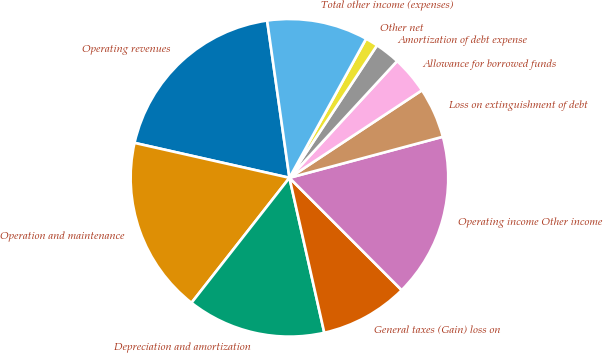Convert chart. <chart><loc_0><loc_0><loc_500><loc_500><pie_chart><fcel>Operating revenues<fcel>Operation and maintenance<fcel>Depreciation and amortization<fcel>General taxes (Gain) loss on<fcel>Operating income Other income<fcel>Loss on extinguishment of debt<fcel>Allowance for borrowed funds<fcel>Amortization of debt expense<fcel>Other net<fcel>Total other income (expenses)<nl><fcel>19.23%<fcel>17.95%<fcel>14.1%<fcel>8.97%<fcel>16.67%<fcel>5.13%<fcel>3.85%<fcel>2.56%<fcel>1.28%<fcel>10.26%<nl></chart> 